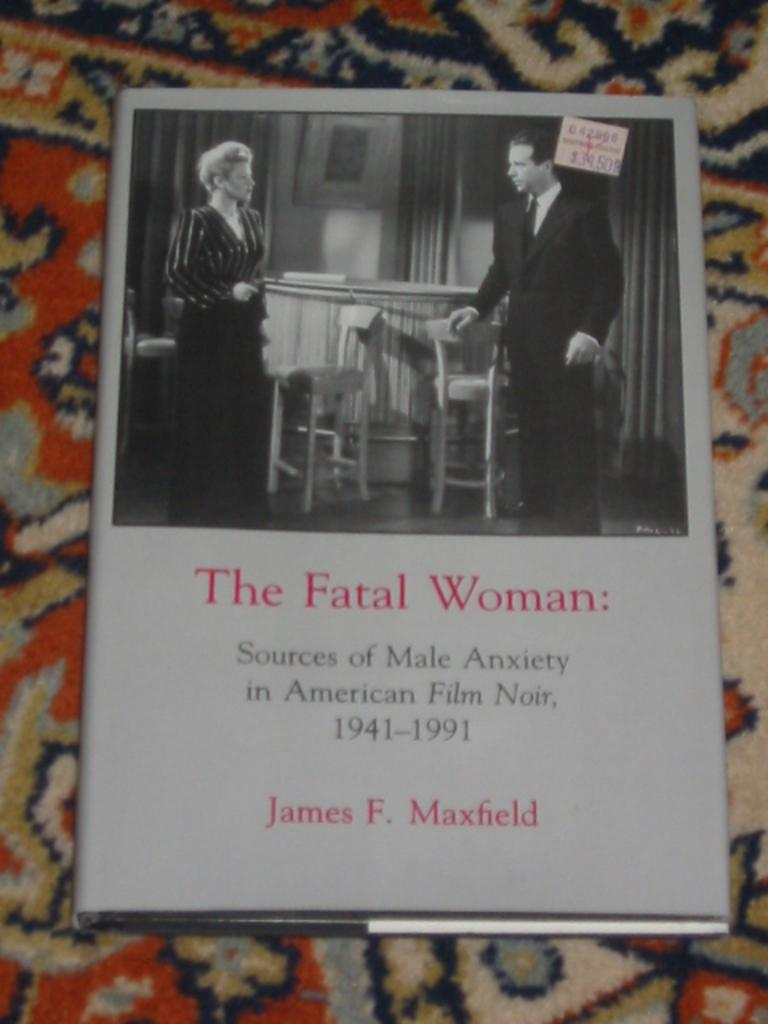What is the main object in the image? There is a book in the image. What is the book placed on? The book is placed on a cloth. Are there any people depicted on the book? Yes, there are two people on the book. What type of furniture is present in the image? There is a table and chairs in the image. What type of window treatment is visible in the image? There are curtains in the image. What additional item can be seen in the image? There is a stamp in the image. Is there any text visible in the image? Yes, there is some text visible in the image. What invention is being discussed in the image? There is no invention being discussed in the image; it primarily features a book with two people on it. 